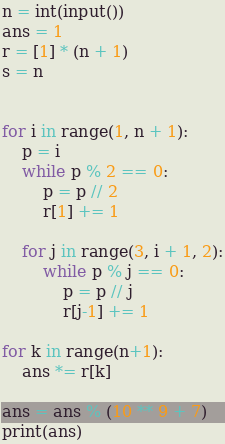Convert code to text. <code><loc_0><loc_0><loc_500><loc_500><_Python_>n = int(input())
ans = 1
r = [1] * (n + 1)
s = n


for i in range(1, n + 1):
    p = i
    while p % 2 == 0:
        p = p // 2
        r[1] += 1

    for j in range(3, i + 1, 2):
        while p % j == 0:
            p = p // j
            r[j-1] += 1

for k in range(n+1):
    ans *= r[k]

ans = ans % (10 ** 9 + 7)
print(ans)</code> 